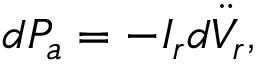<formula> <loc_0><loc_0><loc_500><loc_500>d P _ { a } = - I _ { r } d \ddot { V } _ { r } ,</formula> 